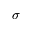Convert formula to latex. <formula><loc_0><loc_0><loc_500><loc_500>\sigma</formula> 